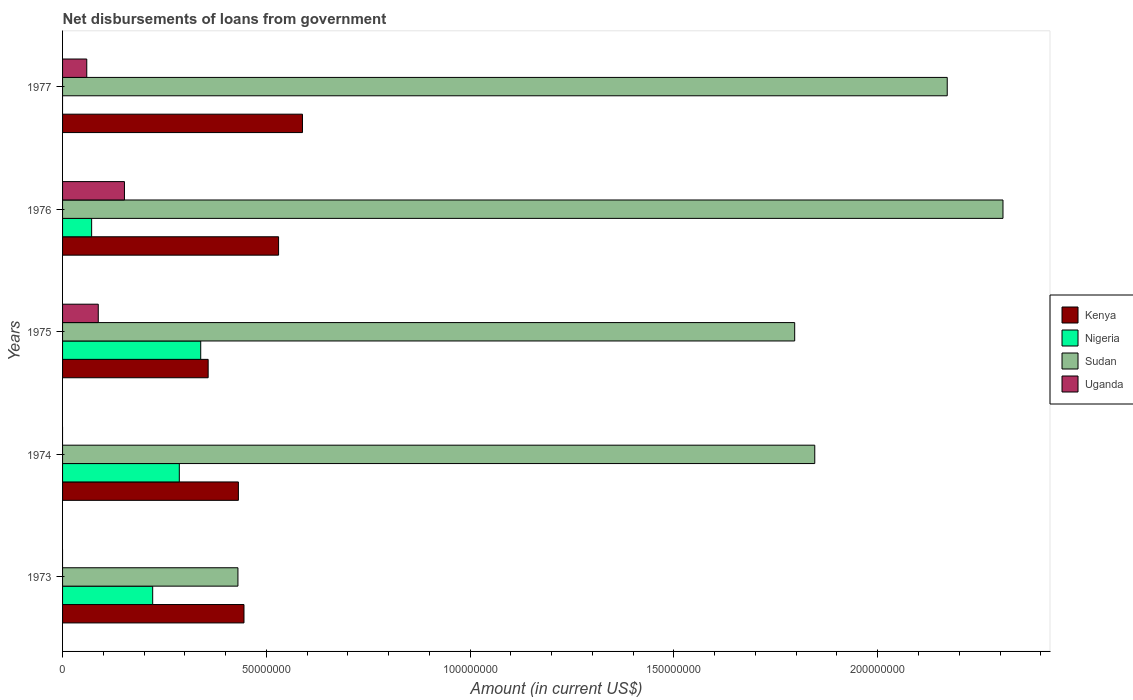Are the number of bars per tick equal to the number of legend labels?
Your answer should be compact. No. How many bars are there on the 1st tick from the bottom?
Your response must be concise. 3. What is the label of the 5th group of bars from the top?
Ensure brevity in your answer.  1973. What is the amount of loan disbursed from government in Nigeria in 1973?
Offer a terse response. 2.21e+07. Across all years, what is the maximum amount of loan disbursed from government in Nigeria?
Give a very brief answer. 3.39e+07. In which year was the amount of loan disbursed from government in Uganda maximum?
Make the answer very short. 1976. What is the total amount of loan disbursed from government in Nigeria in the graph?
Your answer should be compact. 9.18e+07. What is the difference between the amount of loan disbursed from government in Nigeria in 1975 and that in 1976?
Give a very brief answer. 2.68e+07. What is the difference between the amount of loan disbursed from government in Nigeria in 1977 and the amount of loan disbursed from government in Uganda in 1975?
Make the answer very short. -8.76e+06. What is the average amount of loan disbursed from government in Kenya per year?
Ensure brevity in your answer.  4.70e+07. In the year 1974, what is the difference between the amount of loan disbursed from government in Kenya and amount of loan disbursed from government in Sudan?
Offer a terse response. -1.41e+08. What is the ratio of the amount of loan disbursed from government in Sudan in 1975 to that in 1977?
Offer a terse response. 0.83. Is the amount of loan disbursed from government in Nigeria in 1973 less than that in 1976?
Offer a terse response. No. What is the difference between the highest and the second highest amount of loan disbursed from government in Kenya?
Your response must be concise. 5.86e+06. What is the difference between the highest and the lowest amount of loan disbursed from government in Uganda?
Your answer should be very brief. 1.52e+07. Is the sum of the amount of loan disbursed from government in Kenya in 1974 and 1977 greater than the maximum amount of loan disbursed from government in Uganda across all years?
Provide a succinct answer. Yes. Is it the case that in every year, the sum of the amount of loan disbursed from government in Kenya and amount of loan disbursed from government in Uganda is greater than the sum of amount of loan disbursed from government in Nigeria and amount of loan disbursed from government in Sudan?
Provide a short and direct response. No. How many bars are there?
Your response must be concise. 17. Are all the bars in the graph horizontal?
Keep it short and to the point. Yes. What is the difference between two consecutive major ticks on the X-axis?
Your response must be concise. 5.00e+07. Are the values on the major ticks of X-axis written in scientific E-notation?
Provide a succinct answer. No. Does the graph contain grids?
Your answer should be compact. No. Where does the legend appear in the graph?
Give a very brief answer. Center right. How many legend labels are there?
Keep it short and to the point. 4. How are the legend labels stacked?
Make the answer very short. Vertical. What is the title of the graph?
Your answer should be compact. Net disbursements of loans from government. Does "Kenya" appear as one of the legend labels in the graph?
Provide a succinct answer. Yes. What is the Amount (in current US$) in Kenya in 1973?
Make the answer very short. 4.45e+07. What is the Amount (in current US$) of Nigeria in 1973?
Make the answer very short. 2.21e+07. What is the Amount (in current US$) of Sudan in 1973?
Provide a short and direct response. 4.30e+07. What is the Amount (in current US$) of Uganda in 1973?
Give a very brief answer. 0. What is the Amount (in current US$) of Kenya in 1974?
Your response must be concise. 4.31e+07. What is the Amount (in current US$) of Nigeria in 1974?
Keep it short and to the point. 2.86e+07. What is the Amount (in current US$) of Sudan in 1974?
Your response must be concise. 1.85e+08. What is the Amount (in current US$) of Kenya in 1975?
Offer a very short reply. 3.57e+07. What is the Amount (in current US$) of Nigeria in 1975?
Your response must be concise. 3.39e+07. What is the Amount (in current US$) in Sudan in 1975?
Your answer should be very brief. 1.80e+08. What is the Amount (in current US$) in Uganda in 1975?
Ensure brevity in your answer.  8.76e+06. What is the Amount (in current US$) in Kenya in 1976?
Give a very brief answer. 5.30e+07. What is the Amount (in current US$) of Nigeria in 1976?
Your answer should be compact. 7.13e+06. What is the Amount (in current US$) of Sudan in 1976?
Provide a short and direct response. 2.31e+08. What is the Amount (in current US$) of Uganda in 1976?
Offer a very short reply. 1.52e+07. What is the Amount (in current US$) of Kenya in 1977?
Your response must be concise. 5.89e+07. What is the Amount (in current US$) in Nigeria in 1977?
Offer a very short reply. 0. What is the Amount (in current US$) in Sudan in 1977?
Your response must be concise. 2.17e+08. What is the Amount (in current US$) of Uganda in 1977?
Your answer should be compact. 5.94e+06. Across all years, what is the maximum Amount (in current US$) of Kenya?
Ensure brevity in your answer.  5.89e+07. Across all years, what is the maximum Amount (in current US$) of Nigeria?
Offer a very short reply. 3.39e+07. Across all years, what is the maximum Amount (in current US$) of Sudan?
Give a very brief answer. 2.31e+08. Across all years, what is the maximum Amount (in current US$) in Uganda?
Provide a short and direct response. 1.52e+07. Across all years, what is the minimum Amount (in current US$) of Kenya?
Ensure brevity in your answer.  3.57e+07. Across all years, what is the minimum Amount (in current US$) in Sudan?
Provide a succinct answer. 4.30e+07. Across all years, what is the minimum Amount (in current US$) in Uganda?
Provide a short and direct response. 0. What is the total Amount (in current US$) of Kenya in the graph?
Your answer should be very brief. 2.35e+08. What is the total Amount (in current US$) in Nigeria in the graph?
Offer a terse response. 9.18e+07. What is the total Amount (in current US$) of Sudan in the graph?
Keep it short and to the point. 8.55e+08. What is the total Amount (in current US$) of Uganda in the graph?
Make the answer very short. 2.99e+07. What is the difference between the Amount (in current US$) in Kenya in 1973 and that in 1974?
Provide a short and direct response. 1.37e+06. What is the difference between the Amount (in current US$) of Nigeria in 1973 and that in 1974?
Make the answer very short. -6.53e+06. What is the difference between the Amount (in current US$) in Sudan in 1973 and that in 1974?
Your answer should be compact. -1.42e+08. What is the difference between the Amount (in current US$) of Kenya in 1973 and that in 1975?
Offer a terse response. 8.79e+06. What is the difference between the Amount (in current US$) in Nigeria in 1973 and that in 1975?
Keep it short and to the point. -1.18e+07. What is the difference between the Amount (in current US$) in Sudan in 1973 and that in 1975?
Provide a succinct answer. -1.37e+08. What is the difference between the Amount (in current US$) of Kenya in 1973 and that in 1976?
Provide a short and direct response. -8.49e+06. What is the difference between the Amount (in current US$) in Nigeria in 1973 and that in 1976?
Keep it short and to the point. 1.50e+07. What is the difference between the Amount (in current US$) of Sudan in 1973 and that in 1976?
Make the answer very short. -1.88e+08. What is the difference between the Amount (in current US$) in Kenya in 1973 and that in 1977?
Offer a terse response. -1.43e+07. What is the difference between the Amount (in current US$) in Sudan in 1973 and that in 1977?
Make the answer very short. -1.74e+08. What is the difference between the Amount (in current US$) in Kenya in 1974 and that in 1975?
Your response must be concise. 7.42e+06. What is the difference between the Amount (in current US$) of Nigeria in 1974 and that in 1975?
Your response must be concise. -5.25e+06. What is the difference between the Amount (in current US$) in Sudan in 1974 and that in 1975?
Make the answer very short. 4.92e+06. What is the difference between the Amount (in current US$) in Kenya in 1974 and that in 1976?
Your answer should be compact. -9.86e+06. What is the difference between the Amount (in current US$) of Nigeria in 1974 and that in 1976?
Provide a succinct answer. 2.15e+07. What is the difference between the Amount (in current US$) of Sudan in 1974 and that in 1976?
Provide a succinct answer. -4.62e+07. What is the difference between the Amount (in current US$) of Kenya in 1974 and that in 1977?
Offer a terse response. -1.57e+07. What is the difference between the Amount (in current US$) of Sudan in 1974 and that in 1977?
Your answer should be very brief. -3.25e+07. What is the difference between the Amount (in current US$) of Kenya in 1975 and that in 1976?
Provide a short and direct response. -1.73e+07. What is the difference between the Amount (in current US$) of Nigeria in 1975 and that in 1976?
Your response must be concise. 2.68e+07. What is the difference between the Amount (in current US$) in Sudan in 1975 and that in 1976?
Your response must be concise. -5.11e+07. What is the difference between the Amount (in current US$) in Uganda in 1975 and that in 1976?
Your answer should be very brief. -6.42e+06. What is the difference between the Amount (in current US$) in Kenya in 1975 and that in 1977?
Give a very brief answer. -2.31e+07. What is the difference between the Amount (in current US$) in Sudan in 1975 and that in 1977?
Your answer should be very brief. -3.74e+07. What is the difference between the Amount (in current US$) in Uganda in 1975 and that in 1977?
Ensure brevity in your answer.  2.82e+06. What is the difference between the Amount (in current US$) of Kenya in 1976 and that in 1977?
Ensure brevity in your answer.  -5.86e+06. What is the difference between the Amount (in current US$) of Sudan in 1976 and that in 1977?
Offer a very short reply. 1.37e+07. What is the difference between the Amount (in current US$) in Uganda in 1976 and that in 1977?
Make the answer very short. 9.24e+06. What is the difference between the Amount (in current US$) in Kenya in 1973 and the Amount (in current US$) in Nigeria in 1974?
Ensure brevity in your answer.  1.59e+07. What is the difference between the Amount (in current US$) of Kenya in 1973 and the Amount (in current US$) of Sudan in 1974?
Give a very brief answer. -1.40e+08. What is the difference between the Amount (in current US$) of Nigeria in 1973 and the Amount (in current US$) of Sudan in 1974?
Your response must be concise. -1.62e+08. What is the difference between the Amount (in current US$) of Kenya in 1973 and the Amount (in current US$) of Nigeria in 1975?
Your answer should be very brief. 1.06e+07. What is the difference between the Amount (in current US$) in Kenya in 1973 and the Amount (in current US$) in Sudan in 1975?
Make the answer very short. -1.35e+08. What is the difference between the Amount (in current US$) of Kenya in 1973 and the Amount (in current US$) of Uganda in 1975?
Offer a very short reply. 3.58e+07. What is the difference between the Amount (in current US$) in Nigeria in 1973 and the Amount (in current US$) in Sudan in 1975?
Give a very brief answer. -1.58e+08. What is the difference between the Amount (in current US$) of Nigeria in 1973 and the Amount (in current US$) of Uganda in 1975?
Offer a terse response. 1.34e+07. What is the difference between the Amount (in current US$) of Sudan in 1973 and the Amount (in current US$) of Uganda in 1975?
Make the answer very short. 3.43e+07. What is the difference between the Amount (in current US$) of Kenya in 1973 and the Amount (in current US$) of Nigeria in 1976?
Make the answer very short. 3.74e+07. What is the difference between the Amount (in current US$) in Kenya in 1973 and the Amount (in current US$) in Sudan in 1976?
Your response must be concise. -1.86e+08. What is the difference between the Amount (in current US$) in Kenya in 1973 and the Amount (in current US$) in Uganda in 1976?
Offer a very short reply. 2.93e+07. What is the difference between the Amount (in current US$) of Nigeria in 1973 and the Amount (in current US$) of Sudan in 1976?
Your answer should be very brief. -2.09e+08. What is the difference between the Amount (in current US$) in Nigeria in 1973 and the Amount (in current US$) in Uganda in 1976?
Offer a very short reply. 6.93e+06. What is the difference between the Amount (in current US$) of Sudan in 1973 and the Amount (in current US$) of Uganda in 1976?
Offer a very short reply. 2.78e+07. What is the difference between the Amount (in current US$) of Kenya in 1973 and the Amount (in current US$) of Sudan in 1977?
Give a very brief answer. -1.73e+08. What is the difference between the Amount (in current US$) of Kenya in 1973 and the Amount (in current US$) of Uganda in 1977?
Your answer should be compact. 3.86e+07. What is the difference between the Amount (in current US$) in Nigeria in 1973 and the Amount (in current US$) in Sudan in 1977?
Make the answer very short. -1.95e+08. What is the difference between the Amount (in current US$) in Nigeria in 1973 and the Amount (in current US$) in Uganda in 1977?
Ensure brevity in your answer.  1.62e+07. What is the difference between the Amount (in current US$) of Sudan in 1973 and the Amount (in current US$) of Uganda in 1977?
Keep it short and to the point. 3.71e+07. What is the difference between the Amount (in current US$) of Kenya in 1974 and the Amount (in current US$) of Nigeria in 1975?
Your answer should be very brief. 9.24e+06. What is the difference between the Amount (in current US$) of Kenya in 1974 and the Amount (in current US$) of Sudan in 1975?
Provide a succinct answer. -1.36e+08. What is the difference between the Amount (in current US$) in Kenya in 1974 and the Amount (in current US$) in Uganda in 1975?
Provide a succinct answer. 3.44e+07. What is the difference between the Amount (in current US$) in Nigeria in 1974 and the Amount (in current US$) in Sudan in 1975?
Your response must be concise. -1.51e+08. What is the difference between the Amount (in current US$) of Nigeria in 1974 and the Amount (in current US$) of Uganda in 1975?
Your answer should be compact. 1.99e+07. What is the difference between the Amount (in current US$) in Sudan in 1974 and the Amount (in current US$) in Uganda in 1975?
Provide a short and direct response. 1.76e+08. What is the difference between the Amount (in current US$) of Kenya in 1974 and the Amount (in current US$) of Nigeria in 1976?
Provide a succinct answer. 3.60e+07. What is the difference between the Amount (in current US$) in Kenya in 1974 and the Amount (in current US$) in Sudan in 1976?
Provide a short and direct response. -1.88e+08. What is the difference between the Amount (in current US$) of Kenya in 1974 and the Amount (in current US$) of Uganda in 1976?
Ensure brevity in your answer.  2.80e+07. What is the difference between the Amount (in current US$) of Nigeria in 1974 and the Amount (in current US$) of Sudan in 1976?
Keep it short and to the point. -2.02e+08. What is the difference between the Amount (in current US$) of Nigeria in 1974 and the Amount (in current US$) of Uganda in 1976?
Give a very brief answer. 1.35e+07. What is the difference between the Amount (in current US$) of Sudan in 1974 and the Amount (in current US$) of Uganda in 1976?
Ensure brevity in your answer.  1.69e+08. What is the difference between the Amount (in current US$) of Kenya in 1974 and the Amount (in current US$) of Sudan in 1977?
Offer a terse response. -1.74e+08. What is the difference between the Amount (in current US$) in Kenya in 1974 and the Amount (in current US$) in Uganda in 1977?
Provide a short and direct response. 3.72e+07. What is the difference between the Amount (in current US$) in Nigeria in 1974 and the Amount (in current US$) in Sudan in 1977?
Make the answer very short. -1.88e+08. What is the difference between the Amount (in current US$) in Nigeria in 1974 and the Amount (in current US$) in Uganda in 1977?
Provide a short and direct response. 2.27e+07. What is the difference between the Amount (in current US$) in Sudan in 1974 and the Amount (in current US$) in Uganda in 1977?
Offer a terse response. 1.79e+08. What is the difference between the Amount (in current US$) in Kenya in 1975 and the Amount (in current US$) in Nigeria in 1976?
Give a very brief answer. 2.86e+07. What is the difference between the Amount (in current US$) of Kenya in 1975 and the Amount (in current US$) of Sudan in 1976?
Your response must be concise. -1.95e+08. What is the difference between the Amount (in current US$) in Kenya in 1975 and the Amount (in current US$) in Uganda in 1976?
Give a very brief answer. 2.05e+07. What is the difference between the Amount (in current US$) in Nigeria in 1975 and the Amount (in current US$) in Sudan in 1976?
Offer a terse response. -1.97e+08. What is the difference between the Amount (in current US$) in Nigeria in 1975 and the Amount (in current US$) in Uganda in 1976?
Provide a short and direct response. 1.87e+07. What is the difference between the Amount (in current US$) of Sudan in 1975 and the Amount (in current US$) of Uganda in 1976?
Your answer should be very brief. 1.64e+08. What is the difference between the Amount (in current US$) of Kenya in 1975 and the Amount (in current US$) of Sudan in 1977?
Your answer should be very brief. -1.81e+08. What is the difference between the Amount (in current US$) of Kenya in 1975 and the Amount (in current US$) of Uganda in 1977?
Offer a very short reply. 2.98e+07. What is the difference between the Amount (in current US$) of Nigeria in 1975 and the Amount (in current US$) of Sudan in 1977?
Your answer should be compact. -1.83e+08. What is the difference between the Amount (in current US$) in Nigeria in 1975 and the Amount (in current US$) in Uganda in 1977?
Offer a terse response. 2.80e+07. What is the difference between the Amount (in current US$) in Sudan in 1975 and the Amount (in current US$) in Uganda in 1977?
Provide a succinct answer. 1.74e+08. What is the difference between the Amount (in current US$) of Kenya in 1976 and the Amount (in current US$) of Sudan in 1977?
Offer a very short reply. -1.64e+08. What is the difference between the Amount (in current US$) in Kenya in 1976 and the Amount (in current US$) in Uganda in 1977?
Your answer should be very brief. 4.71e+07. What is the difference between the Amount (in current US$) of Nigeria in 1976 and the Amount (in current US$) of Sudan in 1977?
Offer a very short reply. -2.10e+08. What is the difference between the Amount (in current US$) in Nigeria in 1976 and the Amount (in current US$) in Uganda in 1977?
Provide a short and direct response. 1.19e+06. What is the difference between the Amount (in current US$) of Sudan in 1976 and the Amount (in current US$) of Uganda in 1977?
Ensure brevity in your answer.  2.25e+08. What is the average Amount (in current US$) of Kenya per year?
Your response must be concise. 4.70e+07. What is the average Amount (in current US$) of Nigeria per year?
Provide a succinct answer. 1.84e+07. What is the average Amount (in current US$) of Sudan per year?
Offer a very short reply. 1.71e+08. What is the average Amount (in current US$) of Uganda per year?
Your response must be concise. 5.98e+06. In the year 1973, what is the difference between the Amount (in current US$) in Kenya and Amount (in current US$) in Nigeria?
Provide a succinct answer. 2.24e+07. In the year 1973, what is the difference between the Amount (in current US$) of Kenya and Amount (in current US$) of Sudan?
Offer a terse response. 1.48e+06. In the year 1973, what is the difference between the Amount (in current US$) in Nigeria and Amount (in current US$) in Sudan?
Your answer should be compact. -2.09e+07. In the year 1974, what is the difference between the Amount (in current US$) of Kenya and Amount (in current US$) of Nigeria?
Your answer should be compact. 1.45e+07. In the year 1974, what is the difference between the Amount (in current US$) of Kenya and Amount (in current US$) of Sudan?
Provide a succinct answer. -1.41e+08. In the year 1974, what is the difference between the Amount (in current US$) in Nigeria and Amount (in current US$) in Sudan?
Your answer should be compact. -1.56e+08. In the year 1975, what is the difference between the Amount (in current US$) of Kenya and Amount (in current US$) of Nigeria?
Keep it short and to the point. 1.83e+06. In the year 1975, what is the difference between the Amount (in current US$) of Kenya and Amount (in current US$) of Sudan?
Ensure brevity in your answer.  -1.44e+08. In the year 1975, what is the difference between the Amount (in current US$) of Kenya and Amount (in current US$) of Uganda?
Keep it short and to the point. 2.70e+07. In the year 1975, what is the difference between the Amount (in current US$) of Nigeria and Amount (in current US$) of Sudan?
Your answer should be very brief. -1.46e+08. In the year 1975, what is the difference between the Amount (in current US$) of Nigeria and Amount (in current US$) of Uganda?
Provide a succinct answer. 2.51e+07. In the year 1975, what is the difference between the Amount (in current US$) in Sudan and Amount (in current US$) in Uganda?
Ensure brevity in your answer.  1.71e+08. In the year 1976, what is the difference between the Amount (in current US$) in Kenya and Amount (in current US$) in Nigeria?
Provide a succinct answer. 4.59e+07. In the year 1976, what is the difference between the Amount (in current US$) in Kenya and Amount (in current US$) in Sudan?
Provide a short and direct response. -1.78e+08. In the year 1976, what is the difference between the Amount (in current US$) in Kenya and Amount (in current US$) in Uganda?
Your answer should be compact. 3.78e+07. In the year 1976, what is the difference between the Amount (in current US$) in Nigeria and Amount (in current US$) in Sudan?
Offer a very short reply. -2.24e+08. In the year 1976, what is the difference between the Amount (in current US$) in Nigeria and Amount (in current US$) in Uganda?
Offer a terse response. -8.05e+06. In the year 1976, what is the difference between the Amount (in current US$) in Sudan and Amount (in current US$) in Uganda?
Offer a terse response. 2.16e+08. In the year 1977, what is the difference between the Amount (in current US$) of Kenya and Amount (in current US$) of Sudan?
Keep it short and to the point. -1.58e+08. In the year 1977, what is the difference between the Amount (in current US$) in Kenya and Amount (in current US$) in Uganda?
Ensure brevity in your answer.  5.29e+07. In the year 1977, what is the difference between the Amount (in current US$) of Sudan and Amount (in current US$) of Uganda?
Ensure brevity in your answer.  2.11e+08. What is the ratio of the Amount (in current US$) of Kenya in 1973 to that in 1974?
Give a very brief answer. 1.03. What is the ratio of the Amount (in current US$) of Nigeria in 1973 to that in 1974?
Your answer should be very brief. 0.77. What is the ratio of the Amount (in current US$) of Sudan in 1973 to that in 1974?
Make the answer very short. 0.23. What is the ratio of the Amount (in current US$) of Kenya in 1973 to that in 1975?
Provide a succinct answer. 1.25. What is the ratio of the Amount (in current US$) in Nigeria in 1973 to that in 1975?
Offer a terse response. 0.65. What is the ratio of the Amount (in current US$) in Sudan in 1973 to that in 1975?
Keep it short and to the point. 0.24. What is the ratio of the Amount (in current US$) in Kenya in 1973 to that in 1976?
Keep it short and to the point. 0.84. What is the ratio of the Amount (in current US$) of Nigeria in 1973 to that in 1976?
Make the answer very short. 3.1. What is the ratio of the Amount (in current US$) of Sudan in 1973 to that in 1976?
Provide a succinct answer. 0.19. What is the ratio of the Amount (in current US$) of Kenya in 1973 to that in 1977?
Give a very brief answer. 0.76. What is the ratio of the Amount (in current US$) in Sudan in 1973 to that in 1977?
Offer a terse response. 0.2. What is the ratio of the Amount (in current US$) of Kenya in 1974 to that in 1975?
Your response must be concise. 1.21. What is the ratio of the Amount (in current US$) of Nigeria in 1974 to that in 1975?
Ensure brevity in your answer.  0.85. What is the ratio of the Amount (in current US$) of Sudan in 1974 to that in 1975?
Ensure brevity in your answer.  1.03. What is the ratio of the Amount (in current US$) of Kenya in 1974 to that in 1976?
Make the answer very short. 0.81. What is the ratio of the Amount (in current US$) of Nigeria in 1974 to that in 1976?
Your response must be concise. 4.02. What is the ratio of the Amount (in current US$) in Sudan in 1974 to that in 1976?
Keep it short and to the point. 0.8. What is the ratio of the Amount (in current US$) of Kenya in 1974 to that in 1977?
Give a very brief answer. 0.73. What is the ratio of the Amount (in current US$) in Sudan in 1974 to that in 1977?
Offer a terse response. 0.85. What is the ratio of the Amount (in current US$) of Kenya in 1975 to that in 1976?
Ensure brevity in your answer.  0.67. What is the ratio of the Amount (in current US$) in Nigeria in 1975 to that in 1976?
Provide a succinct answer. 4.75. What is the ratio of the Amount (in current US$) in Sudan in 1975 to that in 1976?
Your response must be concise. 0.78. What is the ratio of the Amount (in current US$) in Uganda in 1975 to that in 1976?
Your answer should be compact. 0.58. What is the ratio of the Amount (in current US$) of Kenya in 1975 to that in 1977?
Make the answer very short. 0.61. What is the ratio of the Amount (in current US$) in Sudan in 1975 to that in 1977?
Provide a short and direct response. 0.83. What is the ratio of the Amount (in current US$) of Uganda in 1975 to that in 1977?
Offer a terse response. 1.48. What is the ratio of the Amount (in current US$) in Kenya in 1976 to that in 1977?
Offer a terse response. 0.9. What is the ratio of the Amount (in current US$) in Sudan in 1976 to that in 1977?
Offer a very short reply. 1.06. What is the ratio of the Amount (in current US$) in Uganda in 1976 to that in 1977?
Your answer should be very brief. 2.56. What is the difference between the highest and the second highest Amount (in current US$) of Kenya?
Provide a short and direct response. 5.86e+06. What is the difference between the highest and the second highest Amount (in current US$) in Nigeria?
Offer a terse response. 5.25e+06. What is the difference between the highest and the second highest Amount (in current US$) in Sudan?
Make the answer very short. 1.37e+07. What is the difference between the highest and the second highest Amount (in current US$) in Uganda?
Provide a short and direct response. 6.42e+06. What is the difference between the highest and the lowest Amount (in current US$) of Kenya?
Give a very brief answer. 2.31e+07. What is the difference between the highest and the lowest Amount (in current US$) of Nigeria?
Your answer should be very brief. 3.39e+07. What is the difference between the highest and the lowest Amount (in current US$) in Sudan?
Keep it short and to the point. 1.88e+08. What is the difference between the highest and the lowest Amount (in current US$) of Uganda?
Your answer should be very brief. 1.52e+07. 